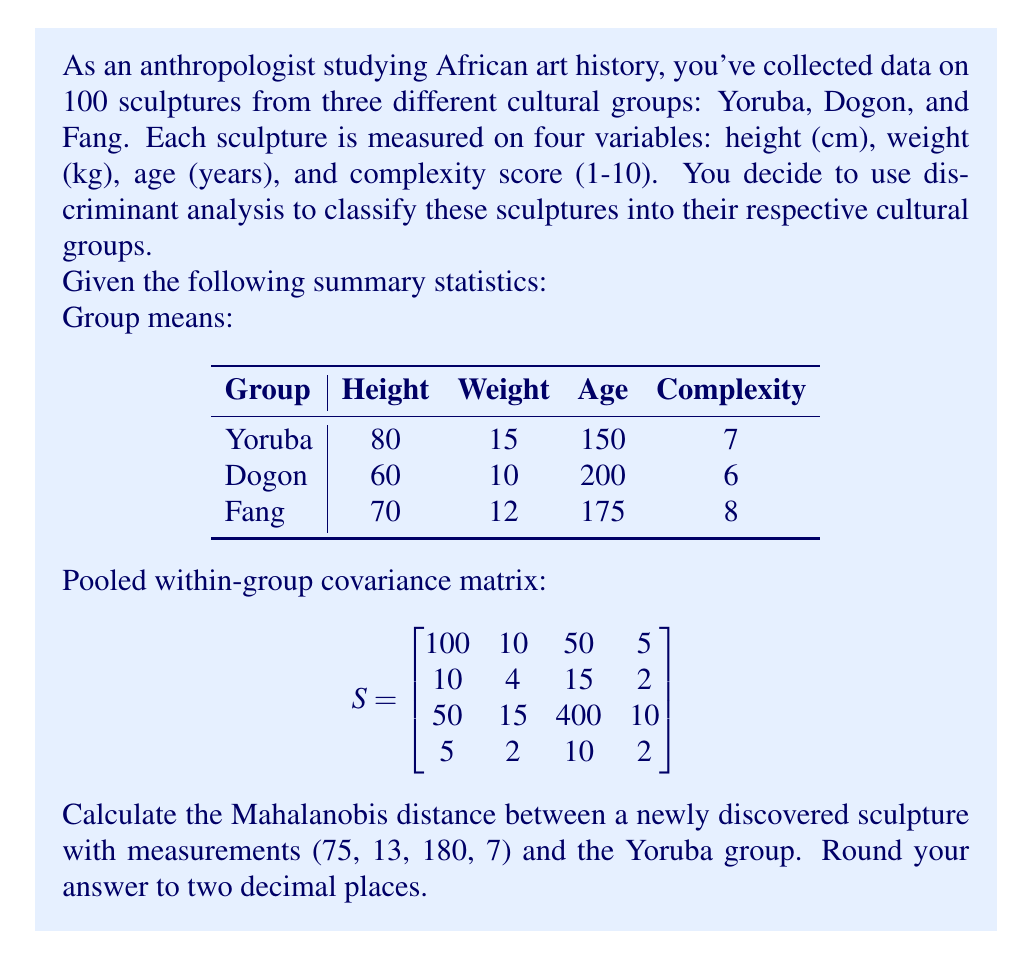Can you answer this question? To solve this problem, we'll use the Mahalanobis distance formula:

$$D^2 = (x - \mu)^T S^{-1} (x - \mu)$$

Where:
- $D^2$ is the squared Mahalanobis distance
- $x$ is the vector of measurements for the new sculpture
- $\mu$ is the mean vector for the Yoruba group
- $S^{-1}$ is the inverse of the pooled within-group covariance matrix

Step 1: Calculate $(x - \mu)$
$$x - \mu = \begin{bmatrix} 75 \\ 13 \\ 180 \\ 7 \end{bmatrix} - \begin{bmatrix} 80 \\ 15 \\ 150 \\ 7 \end{bmatrix} = \begin{bmatrix} -5 \\ -2 \\ 30 \\ 0 \end{bmatrix}$$

Step 2: Calculate $S^{-1}$
Using a calculator or computer, we find:
$$S^{-1} = \begin{bmatrix}
0.0107 & -0.0214 & -0.0012 & -0.0179 \\
-0.0214 & 0.2786 & -0.0054 & 0.0214 \\
-0.0012 & -0.0054 & 0.0027 & -0.0089 \\
-0.0179 & 0.0214 & -0.0089 & 0.5536
\end{bmatrix}$$

Step 3: Calculate $D^2$
$$\begin{align}
D^2 &= \begin{bmatrix} -5 & -2 & 30 & 0 \end{bmatrix} \begin{bmatrix}
0.0107 & -0.0214 & -0.0012 & -0.0179 \\
-0.0214 & 0.2786 & -0.0054 & 0.0214 \\
-0.0012 & -0.0054 & 0.0027 & -0.0089 \\
-0.0179 & 0.0214 & -0.0089 & 0.5536
\end{bmatrix} \begin{bmatrix} -5 \\ -2 \\ 30 \\ 0 \end{bmatrix} \\
&= \begin{bmatrix} -0.2675 & -0.4844 & 0.0810 & 0 \end{bmatrix} \begin{bmatrix} -5 \\ -2 \\ 30 \\ 0 \end{bmatrix} \\
&= 1.3375 + 0.9688 + 2.4300 + 0 \\
&= 4.7363
\end{align}$$

Step 4: Calculate $D$
$$D = \sqrt{4.7363} = 2.1763$$

Rounding to two decimal places, we get 2.18.
Answer: 2.18 